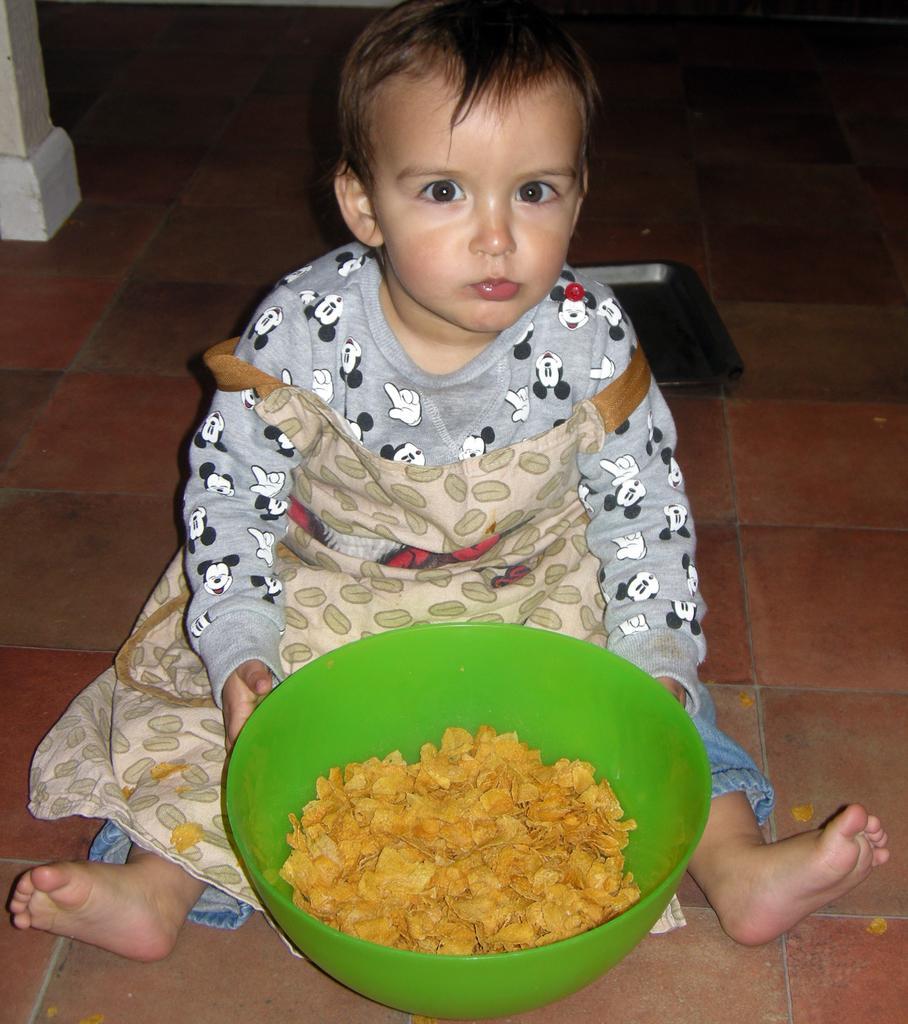Could you give a brief overview of what you see in this image? In the center of the image we can see one kid is sitting and holding a bowl. In the bowl, we can see some food item. In the background, we can see a few other objects. 